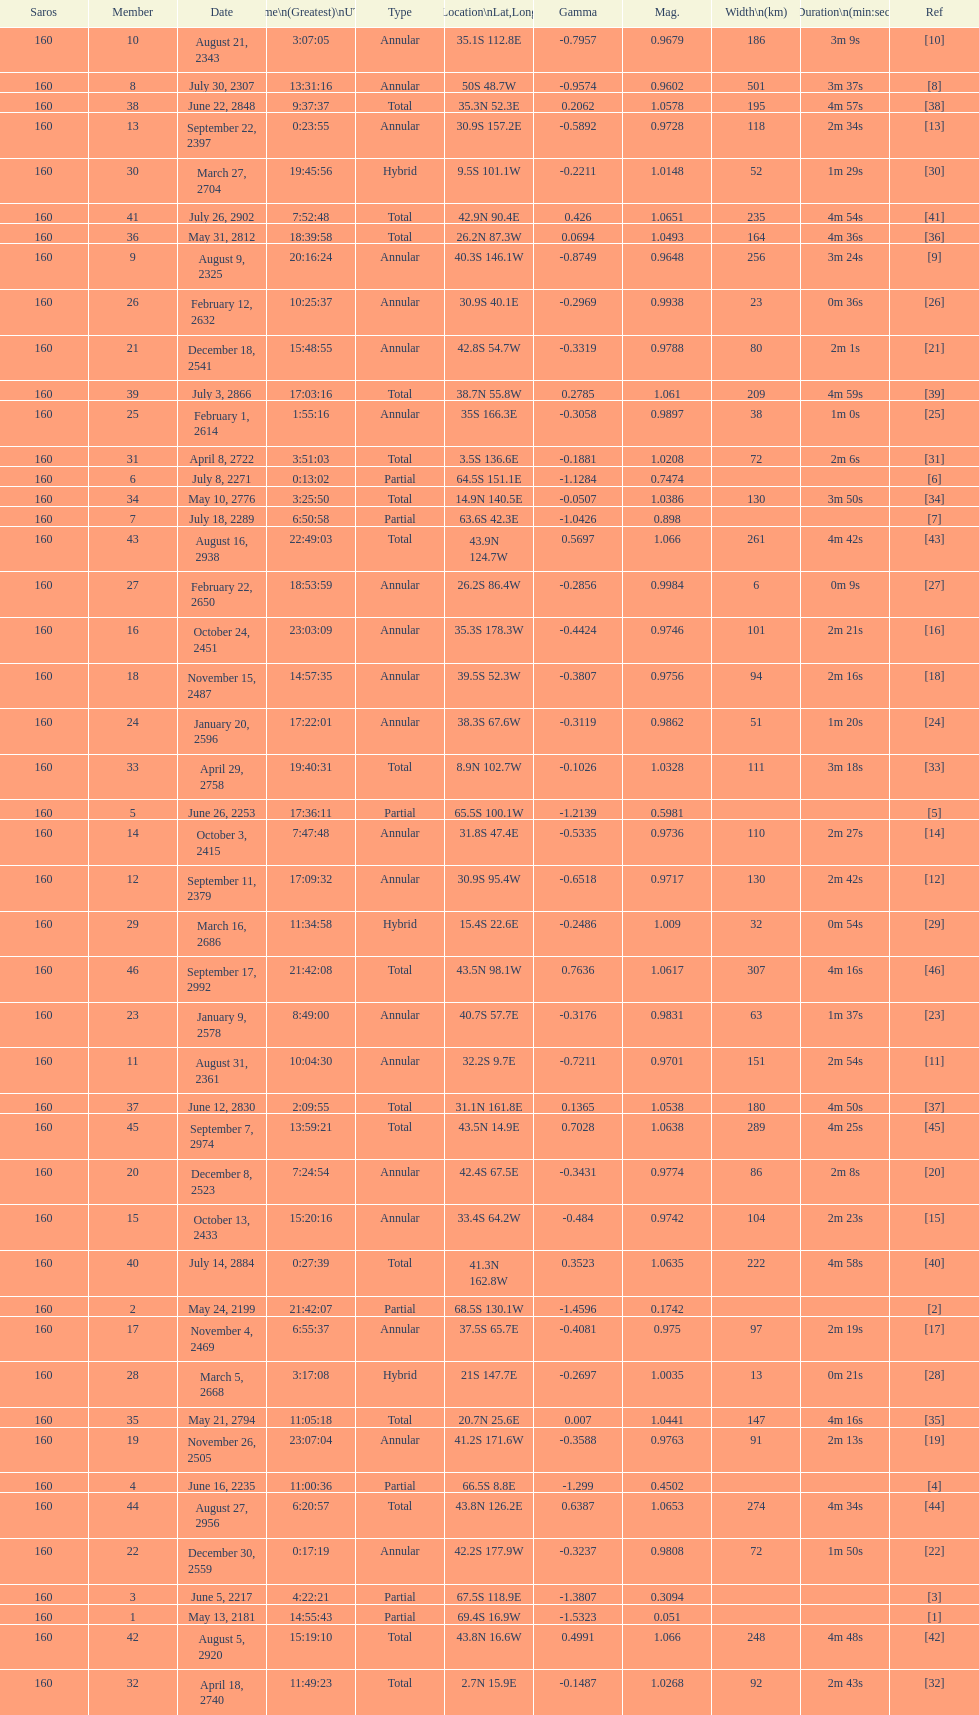Name one that has the same latitude as member number 12. 13. 